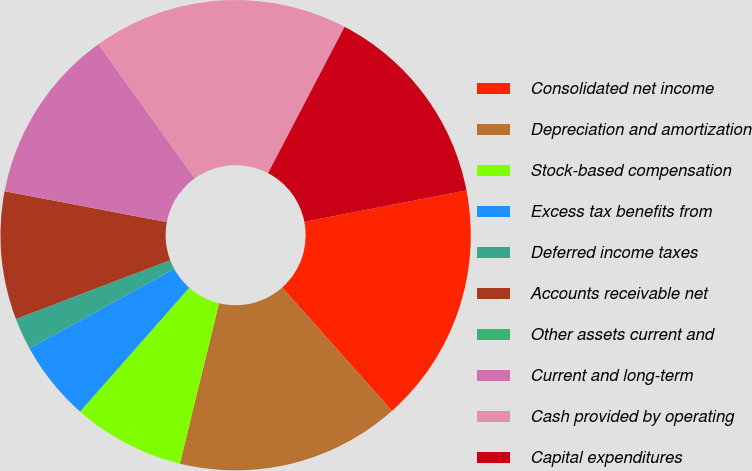Convert chart. <chart><loc_0><loc_0><loc_500><loc_500><pie_chart><fcel>Consolidated net income<fcel>Depreciation and amortization<fcel>Stock-based compensation<fcel>Excess tax benefits from<fcel>Deferred income taxes<fcel>Accounts receivable net<fcel>Other assets current and<fcel>Current and long-term<fcel>Cash provided by operating<fcel>Capital expenditures<nl><fcel>16.48%<fcel>15.38%<fcel>7.69%<fcel>5.5%<fcel>2.2%<fcel>8.79%<fcel>0.0%<fcel>12.09%<fcel>17.58%<fcel>14.28%<nl></chart> 